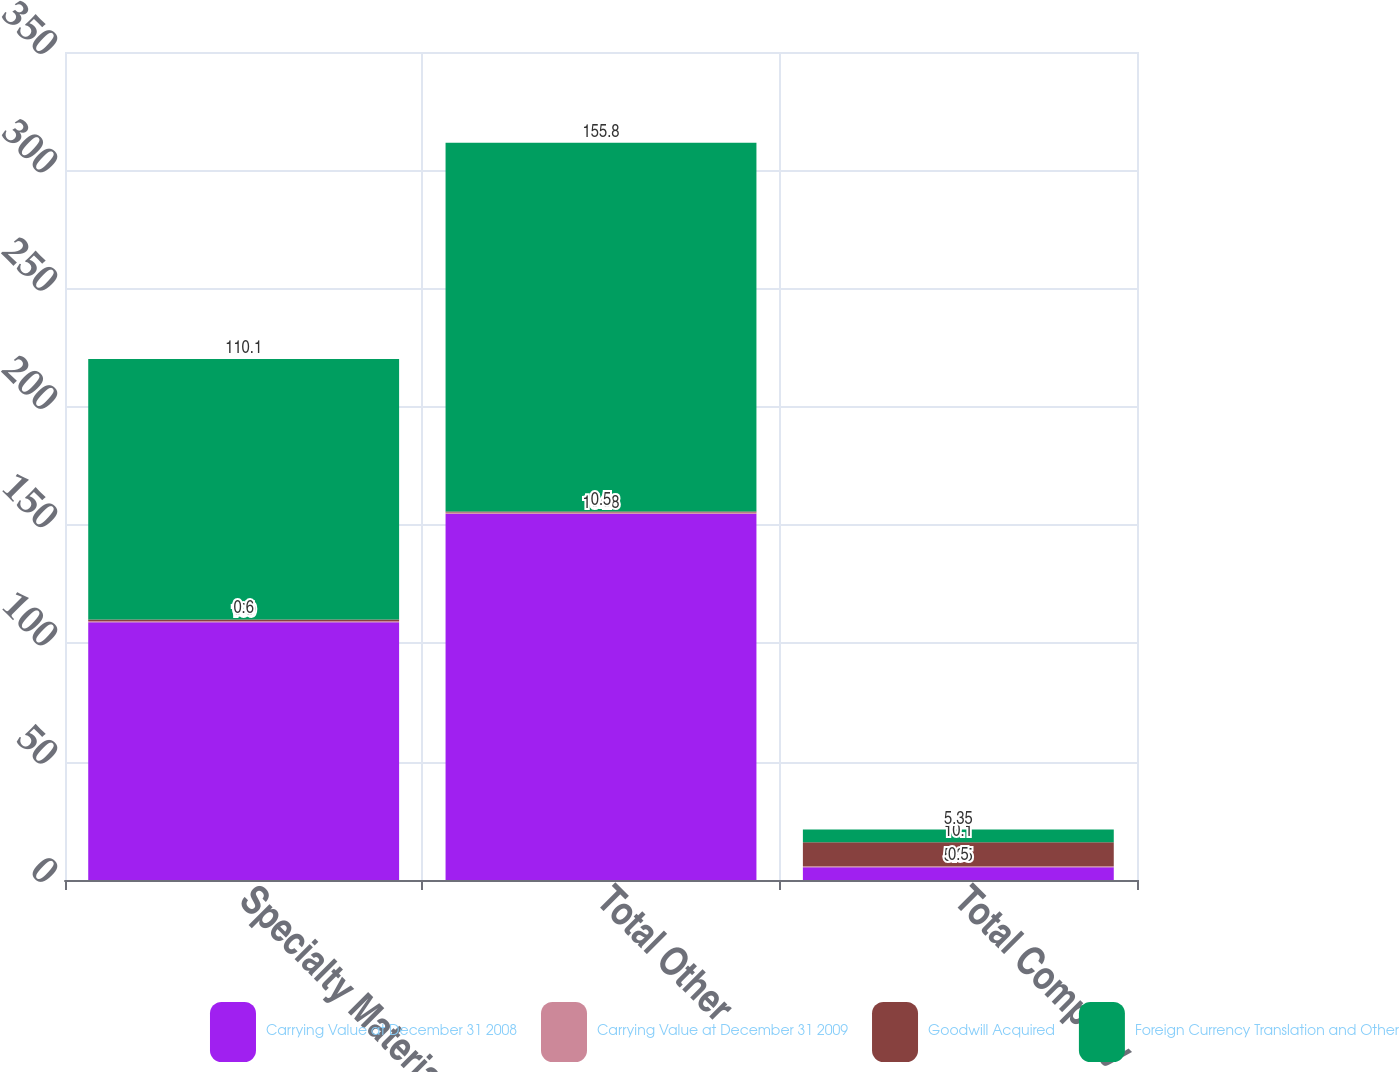<chart> <loc_0><loc_0><loc_500><loc_500><stacked_bar_chart><ecel><fcel>Specialty Materials<fcel>Total Other<fcel>Total Company<nl><fcel>Carrying Value at December 31 2008<fcel>109<fcel>154.8<fcel>5.35<nl><fcel>Carrying Value at December 31 2009<fcel>0.5<fcel>0.5<fcel>0.5<nl><fcel>Goodwill Acquired<fcel>0.6<fcel>0.5<fcel>10.1<nl><fcel>Foreign Currency Translation and Other<fcel>110.1<fcel>155.8<fcel>5.35<nl></chart> 